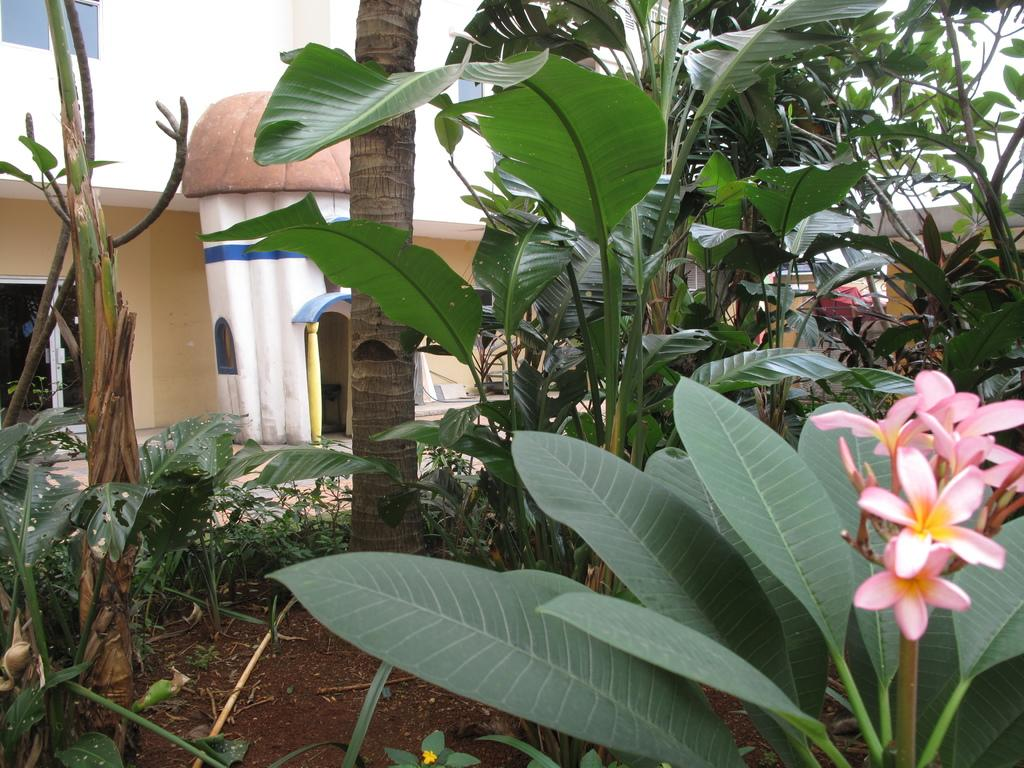What type of structures can be seen in the image? There are buildings in the image. What architectural features are present on the buildings? There are windows and at least one door visible on the buildings. What type of vegetation is present in the image? There are trees, plants, and flowers in the image. What is the surface on which the buildings and vegetation are situated? There is ground visible in the image. What type of nail is being used to hang a painting in the image? There is no painting or nail present in the image. Can you tell me how many ears are visible in the image? There are no ears visible in the image. 